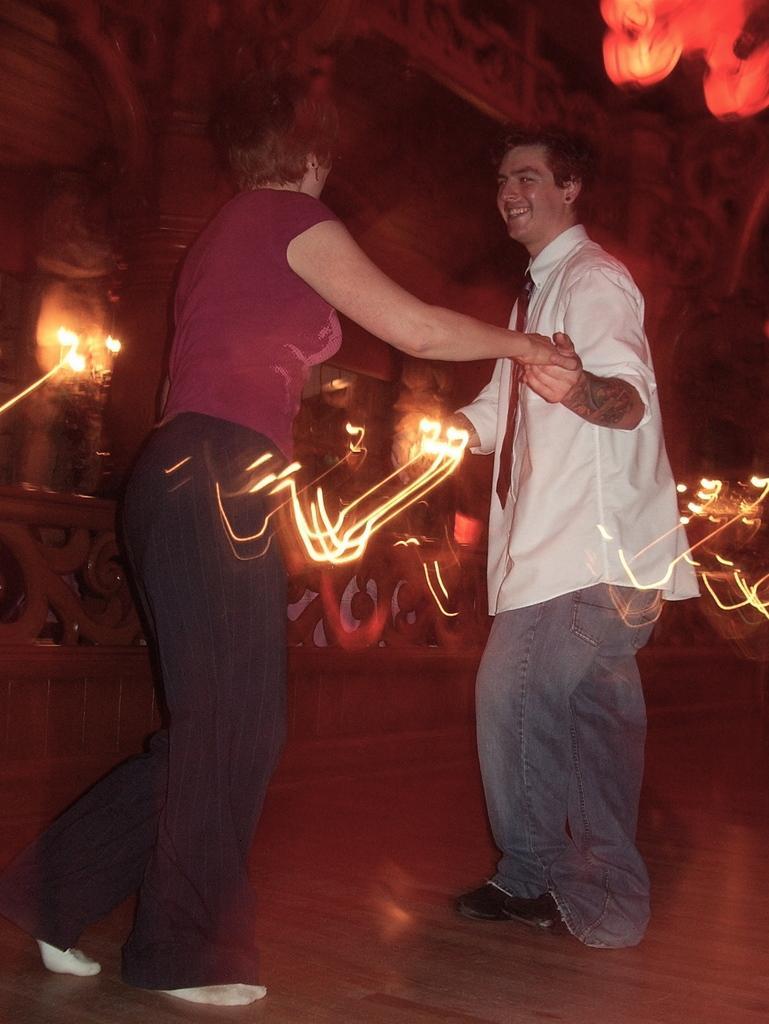In one or two sentences, can you explain what this image depicts? In this picture we can see there are two people dancing on the floor and behind the people there is a wall with lights. 